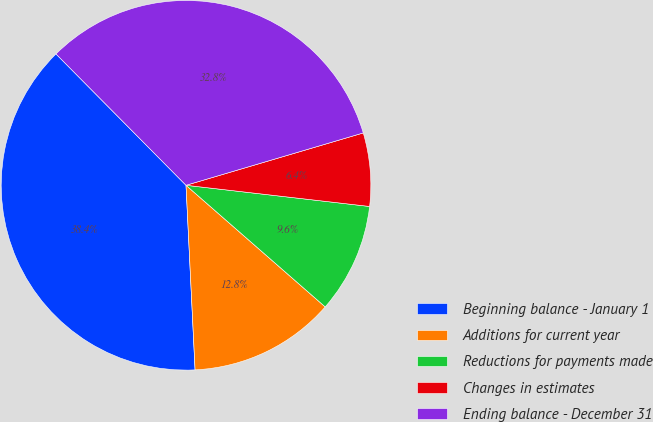Convert chart. <chart><loc_0><loc_0><loc_500><loc_500><pie_chart><fcel>Beginning balance - January 1<fcel>Additions for current year<fcel>Reductions for payments made<fcel>Changes in estimates<fcel>Ending balance - December 31<nl><fcel>38.36%<fcel>12.79%<fcel>9.6%<fcel>6.4%<fcel>32.85%<nl></chart> 